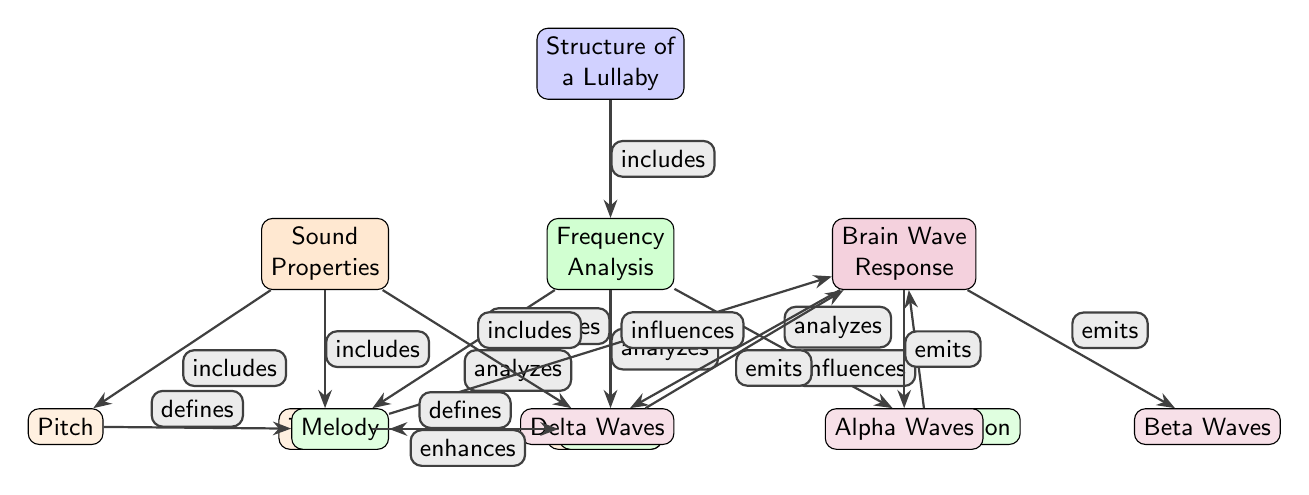What is the main focus of the diagram? The diagram's main focus is highlighted in the top node labeled "Structure of a Lullaby," which summarizes the overall theme of the diagram.
Answer: Structure of a Lullaby How many subcategories are listed under "Frequency Analysis"? Looking at the node for "Frequency Analysis," there are three direct sub-nodes listed: "Melody," "Rhythm," and "Instrumentation." Counting these provides the answer.
Answer: 3 What influences brain activity according to the diagram? The diagram shows arrows from "Melody," "Rhythm," and "Instrumentation" leading to "Brain Wave Response," indicating these properties influence brain activity.
Answer: Melody, Rhythm, Instrumentation What sound property defines melody? The diagram indicates that "Pitch" is connected to and defines "Melody," as shown by the arrow labeled "defines."
Answer: Pitch Which brain wave is emitted from the brain as shown in the diagram? Three specific brain waves are indicated as outputs from the "Brain Wave Response" node: "Delta Waves," "Alpha Waves," and "Beta Waves." The question can be answered by recognizing any of these as correct, but selecting one to indicate a clear answer.
Answer: Delta Waves What connects the "Harmony" node to the "Melody" node? The diagram has an arrow labeled "enhances" indicating that "Harmony" enhances "Melody," thus defining the connection between these two nodes.
Answer: enhances What is the relationship between "Tempo" and "Rhythm"? According to the diagram, there is an arrow pointing from "Tempo" to "Rhythm," labeled as "defines," demonstrating that tempo is a defining factor of rhythm in lullabies.
Answer: defines How is the overall structure of a lullaby characterized? The overall structure of a lullaby is characterized by its elements as shown in the various sub-nodes: Sound Properties, Frequency Analysis, and Brain Wave Response, correlated by the arrows connecting them.
Answer: By its elements What does "Instrumentation" analyze in the context of lullabies? The node labeled "Instrumentation" specifically analyzes sound frequencies and how they contribute to the effectiveness of lullabies in soothing newborns.
Answer: Effectiveness of lullabies 